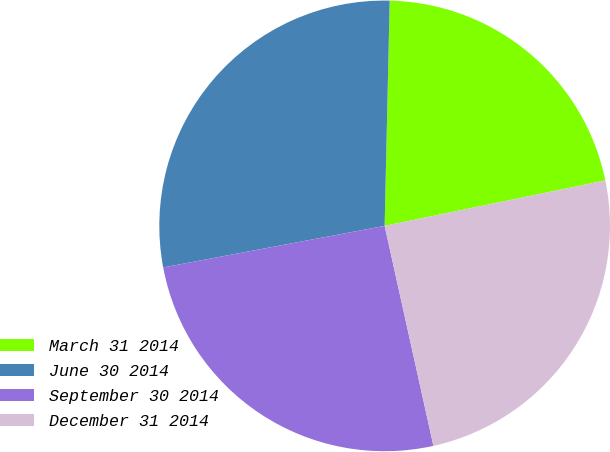Convert chart to OTSL. <chart><loc_0><loc_0><loc_500><loc_500><pie_chart><fcel>March 31 2014<fcel>June 30 2014<fcel>September 30 2014<fcel>December 31 2014<nl><fcel>21.41%<fcel>28.31%<fcel>25.52%<fcel>24.76%<nl></chart> 